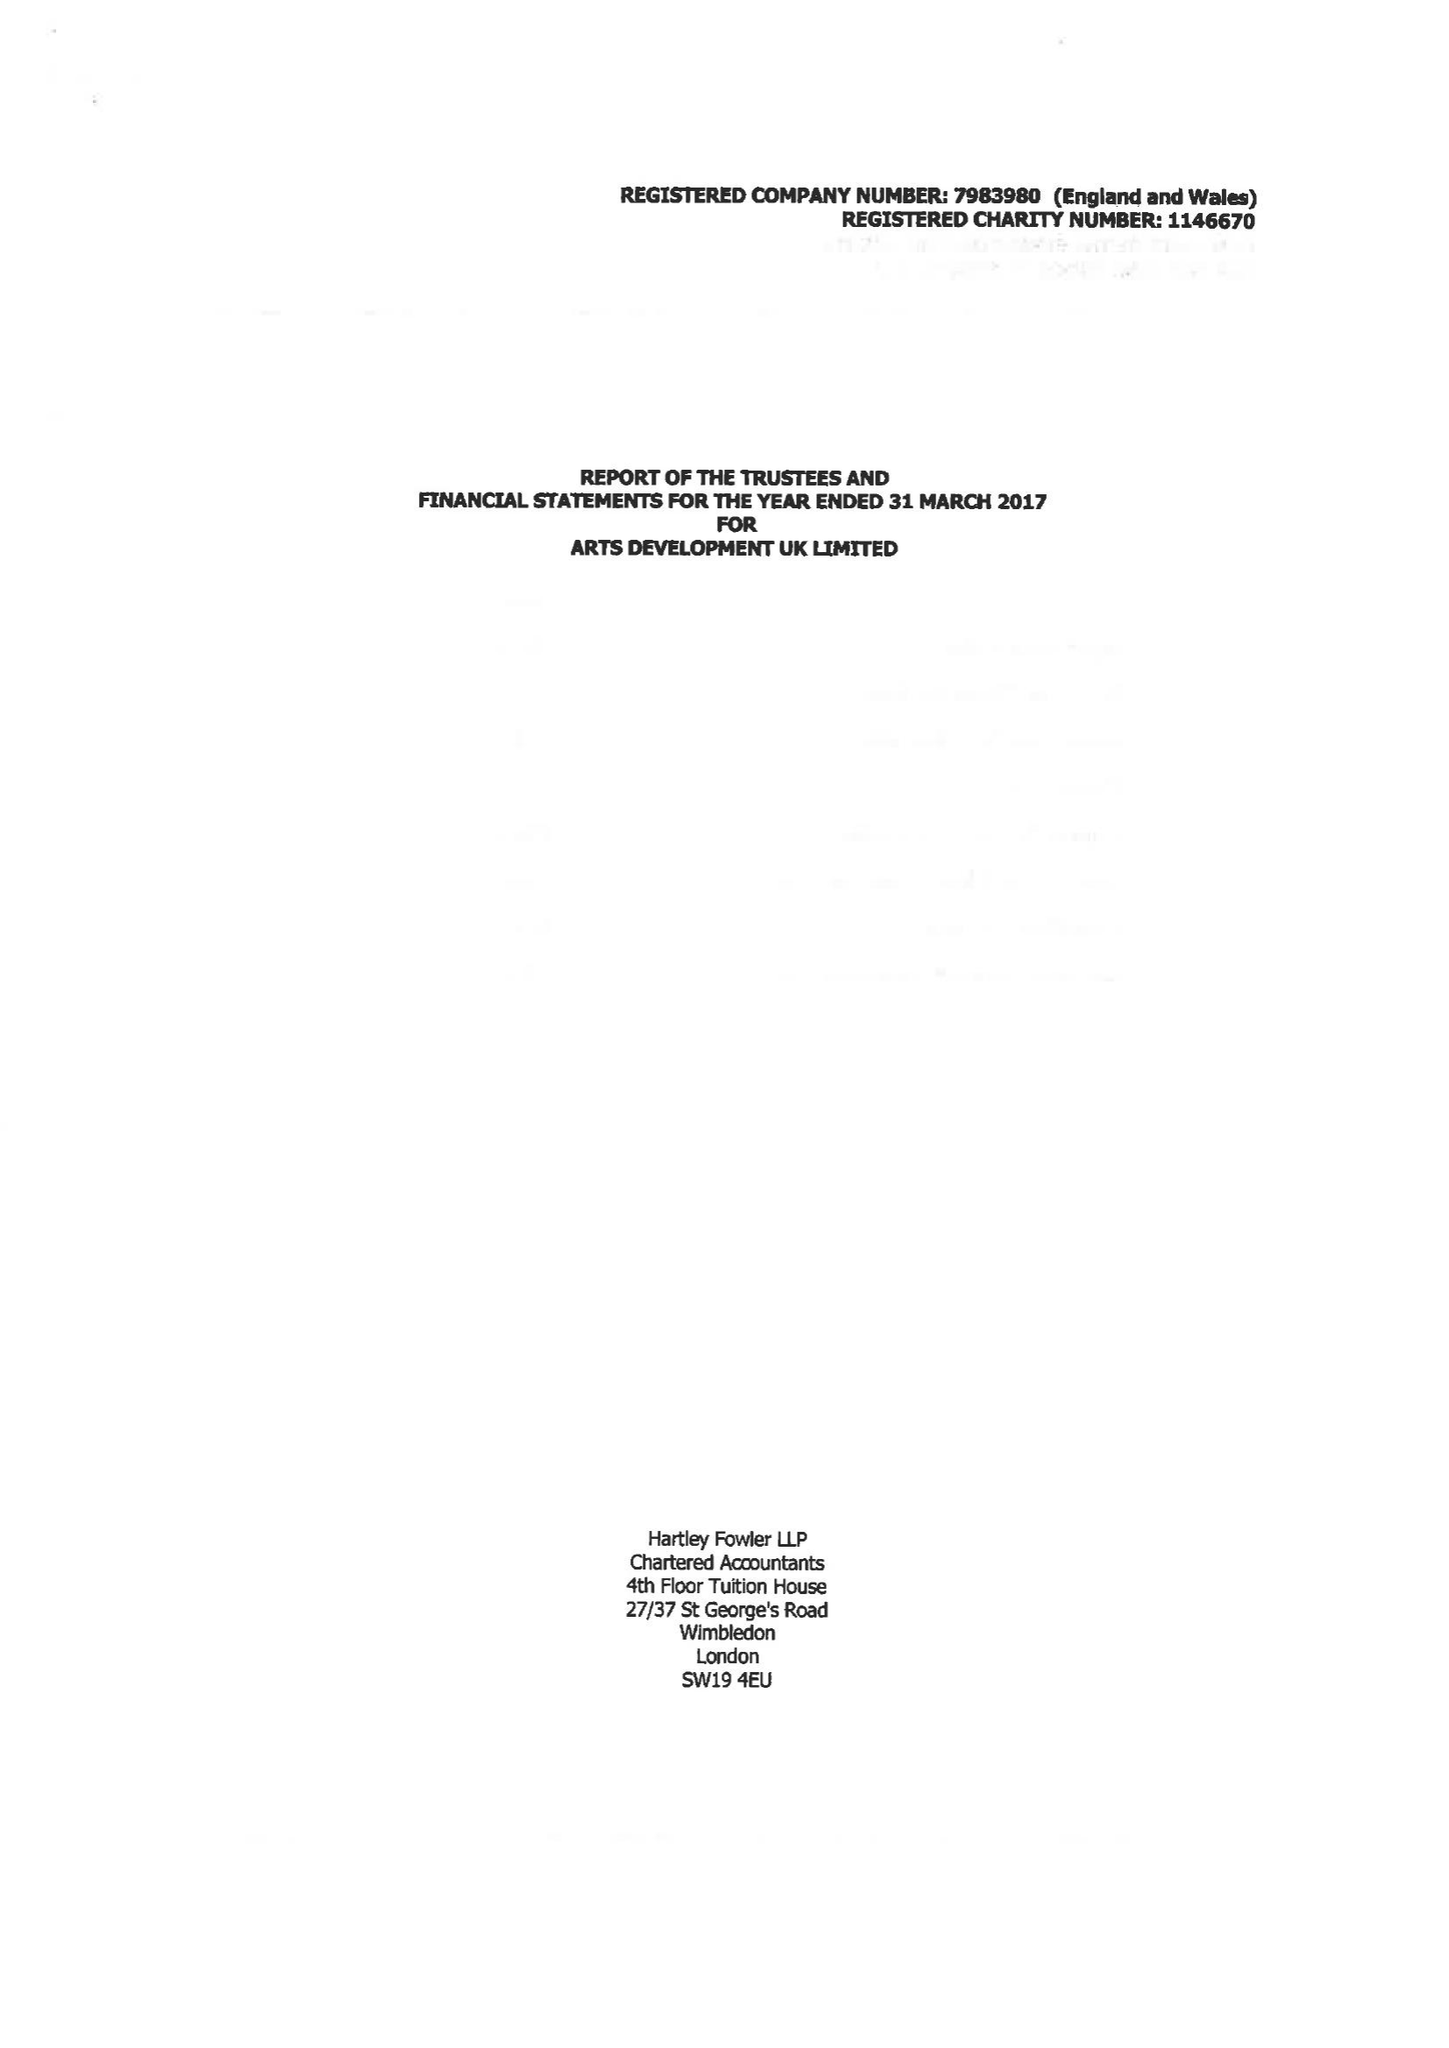What is the value for the income_annually_in_british_pounds?
Answer the question using a single word or phrase. 130376.00 